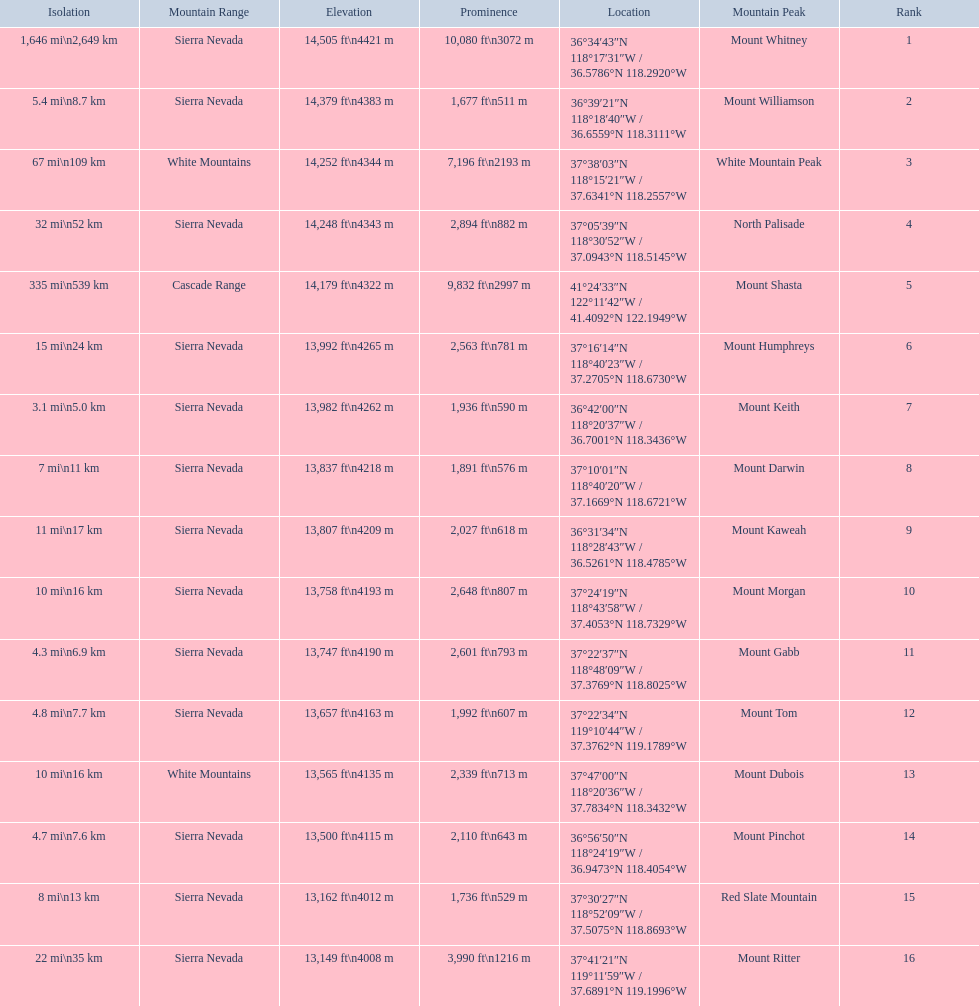Which mountain peaks are lower than 14,000 ft? Mount Humphreys, Mount Keith, Mount Darwin, Mount Kaweah, Mount Morgan, Mount Gabb, Mount Tom, Mount Dubois, Mount Pinchot, Red Slate Mountain, Mount Ritter. Are any of them below 13,500? if so, which ones? Red Slate Mountain, Mount Ritter. What's the lowest peak? 13,149 ft\n4008 m. Which one is that? Mount Ritter. 